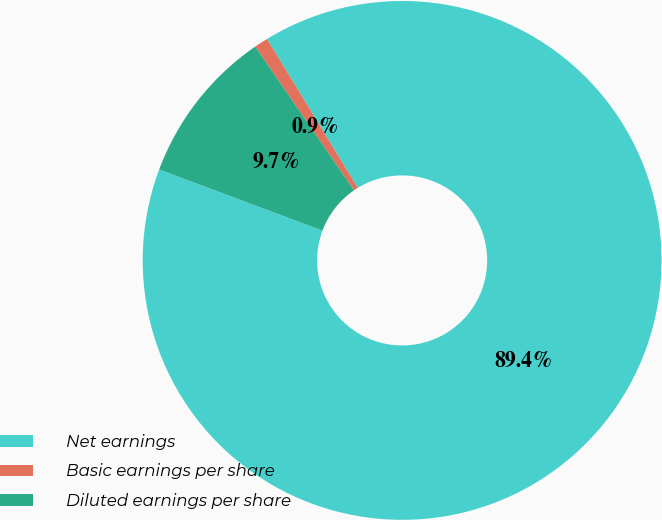Convert chart to OTSL. <chart><loc_0><loc_0><loc_500><loc_500><pie_chart><fcel>Net earnings<fcel>Basic earnings per share<fcel>Diluted earnings per share<nl><fcel>89.41%<fcel>0.86%<fcel>9.72%<nl></chart> 